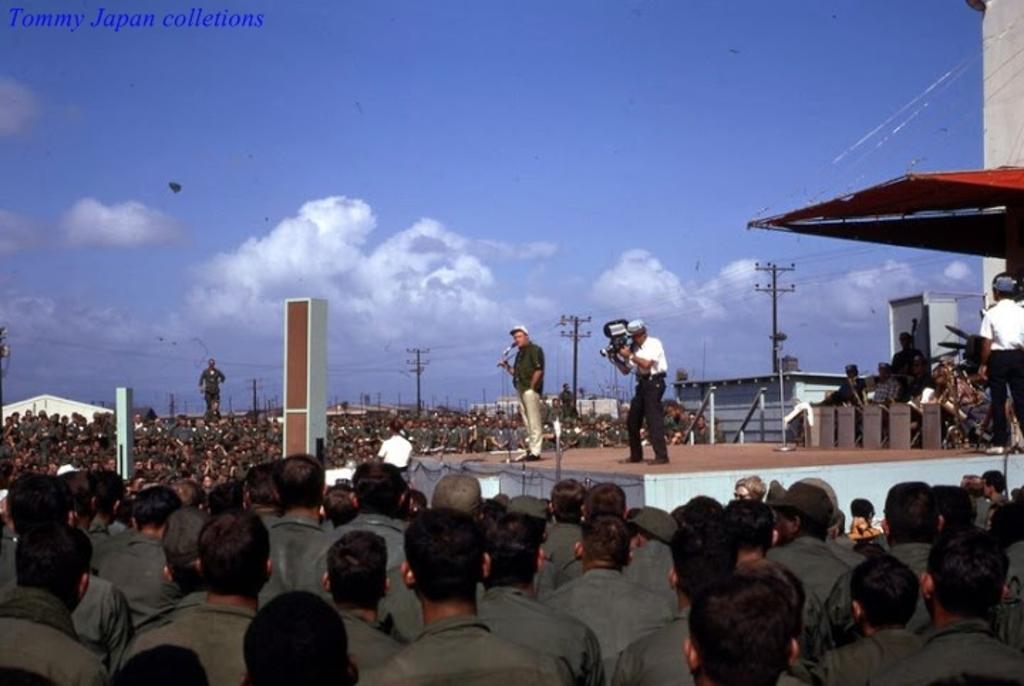Could you give a brief overview of what you see in this image? In the image there are many people. In between them there is a stage. On the stage there is a man with mic is standing. Behind him there is a man holding a video camera in the hand. And on the right side of the image on the stage there is a man standing. At the top of them there is a roof. In the background there are electrical poles with wires and also there are small houses. At the top of the image there is sky with clouds. In the top left corner of the image there is a name. 